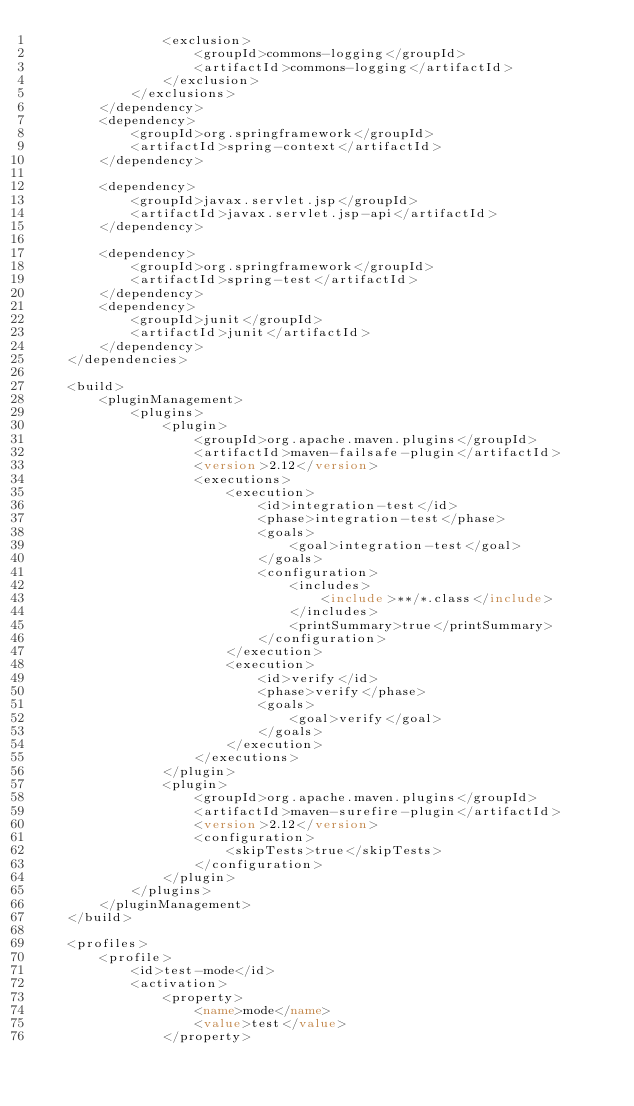<code> <loc_0><loc_0><loc_500><loc_500><_XML_>                <exclusion>
                    <groupId>commons-logging</groupId>
                    <artifactId>commons-logging</artifactId>
                </exclusion>
            </exclusions>
        </dependency>
        <dependency>
            <groupId>org.springframework</groupId>
            <artifactId>spring-context</artifactId>
        </dependency>

        <dependency>
            <groupId>javax.servlet.jsp</groupId>
            <artifactId>javax.servlet.jsp-api</artifactId>
        </dependency>

        <dependency>
            <groupId>org.springframework</groupId>
            <artifactId>spring-test</artifactId>
        </dependency>
        <dependency>
            <groupId>junit</groupId>
            <artifactId>junit</artifactId>
        </dependency>
    </dependencies>

    <build>
        <pluginManagement>
            <plugins>
                <plugin>
                    <groupId>org.apache.maven.plugins</groupId>
                    <artifactId>maven-failsafe-plugin</artifactId>
                    <version>2.12</version>
                    <executions>
                        <execution>
                            <id>integration-test</id>
                            <phase>integration-test</phase>
                            <goals>
                                <goal>integration-test</goal>
                            </goals>
                            <configuration>
                                <includes>
                                    <include>**/*.class</include>
                                </includes>
                                <printSummary>true</printSummary>
                            </configuration>
                        </execution>
                        <execution>
                            <id>verify</id>
                            <phase>verify</phase>
                            <goals>
                                <goal>verify</goal>
                            </goals>
                        </execution>
                    </executions>
                </plugin>
                <plugin>
                    <groupId>org.apache.maven.plugins</groupId>
                    <artifactId>maven-surefire-plugin</artifactId>
                    <version>2.12</version>
                    <configuration>
                        <skipTests>true</skipTests>
                    </configuration>
                </plugin>
            </plugins>
        </pluginManagement>
    </build>

    <profiles>
        <profile>
            <id>test-mode</id>
            <activation>
                <property>
                    <name>mode</name>
                    <value>test</value>
                </property></code> 